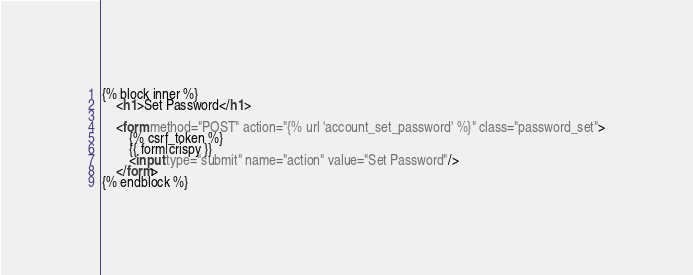Convert code to text. <code><loc_0><loc_0><loc_500><loc_500><_HTML_>{% block inner %}
    <h1>Set Password</h1>

    <form method="POST" action="{% url 'account_set_password' %}" class="password_set">
        {% csrf_token %}
        {{ form|crispy }}
        <input type="submit" name="action" value="Set Password"/>
    </form>
{% endblock %}

</code> 